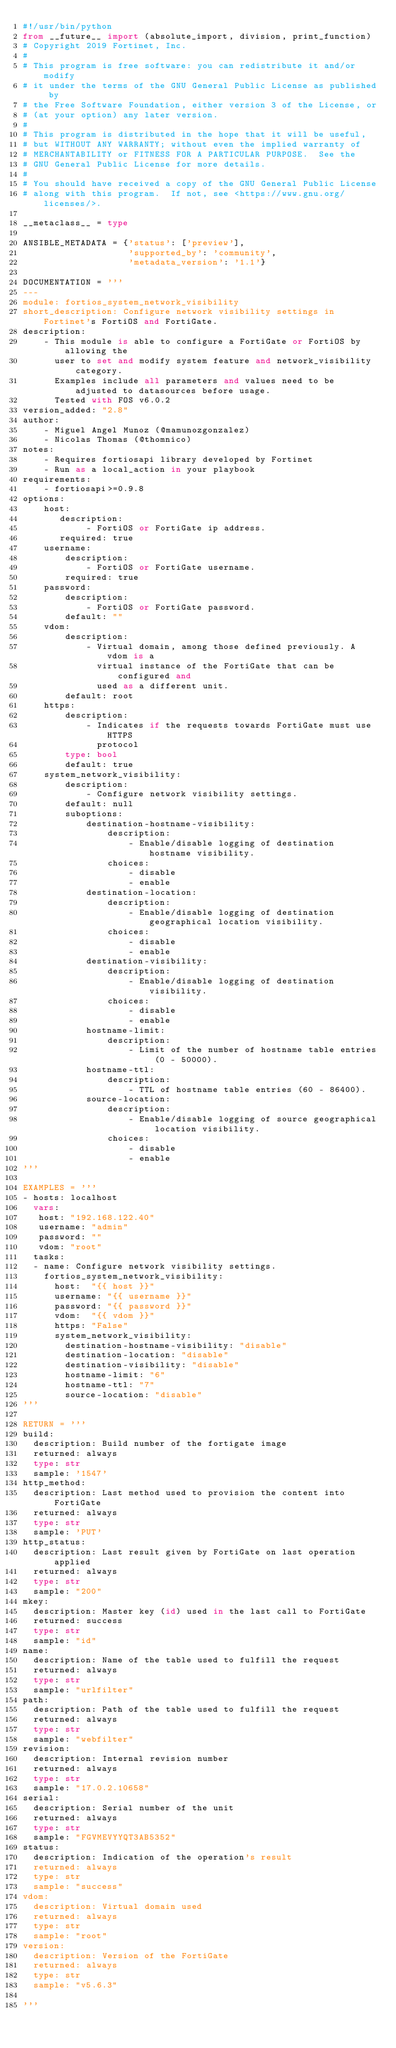<code> <loc_0><loc_0><loc_500><loc_500><_Python_>#!/usr/bin/python
from __future__ import (absolute_import, division, print_function)
# Copyright 2019 Fortinet, Inc.
#
# This program is free software: you can redistribute it and/or modify
# it under the terms of the GNU General Public License as published by
# the Free Software Foundation, either version 3 of the License, or
# (at your option) any later version.
#
# This program is distributed in the hope that it will be useful,
# but WITHOUT ANY WARRANTY; without even the implied warranty of
# MERCHANTABILITY or FITNESS FOR A PARTICULAR PURPOSE.  See the
# GNU General Public License for more details.
#
# You should have received a copy of the GNU General Public License
# along with this program.  If not, see <https://www.gnu.org/licenses/>.

__metaclass__ = type

ANSIBLE_METADATA = {'status': ['preview'],
                    'supported_by': 'community',
                    'metadata_version': '1.1'}

DOCUMENTATION = '''
---
module: fortios_system_network_visibility
short_description: Configure network visibility settings in Fortinet's FortiOS and FortiGate.
description:
    - This module is able to configure a FortiGate or FortiOS by allowing the
      user to set and modify system feature and network_visibility category.
      Examples include all parameters and values need to be adjusted to datasources before usage.
      Tested with FOS v6.0.2
version_added: "2.8"
author:
    - Miguel Angel Munoz (@mamunozgonzalez)
    - Nicolas Thomas (@thomnico)
notes:
    - Requires fortiosapi library developed by Fortinet
    - Run as a local_action in your playbook
requirements:
    - fortiosapi>=0.9.8
options:
    host:
       description:
            - FortiOS or FortiGate ip address.
       required: true
    username:
        description:
            - FortiOS or FortiGate username.
        required: true
    password:
        description:
            - FortiOS or FortiGate password.
        default: ""
    vdom:
        description:
            - Virtual domain, among those defined previously. A vdom is a
              virtual instance of the FortiGate that can be configured and
              used as a different unit.
        default: root
    https:
        description:
            - Indicates if the requests towards FortiGate must use HTTPS
              protocol
        type: bool
        default: true
    system_network_visibility:
        description:
            - Configure network visibility settings.
        default: null
        suboptions:
            destination-hostname-visibility:
                description:
                    - Enable/disable logging of destination hostname visibility.
                choices:
                    - disable
                    - enable
            destination-location:
                description:
                    - Enable/disable logging of destination geographical location visibility.
                choices:
                    - disable
                    - enable
            destination-visibility:
                description:
                    - Enable/disable logging of destination visibility.
                choices:
                    - disable
                    - enable
            hostname-limit:
                description:
                    - Limit of the number of hostname table entries (0 - 50000).
            hostname-ttl:
                description:
                    - TTL of hostname table entries (60 - 86400).
            source-location:
                description:
                    - Enable/disable logging of source geographical location visibility.
                choices:
                    - disable
                    - enable
'''

EXAMPLES = '''
- hosts: localhost
  vars:
   host: "192.168.122.40"
   username: "admin"
   password: ""
   vdom: "root"
  tasks:
  - name: Configure network visibility settings.
    fortios_system_network_visibility:
      host:  "{{ host }}"
      username: "{{ username }}"
      password: "{{ password }}"
      vdom:  "{{ vdom }}"
      https: "False"
      system_network_visibility:
        destination-hostname-visibility: "disable"
        destination-location: "disable"
        destination-visibility: "disable"
        hostname-limit: "6"
        hostname-ttl: "7"
        source-location: "disable"
'''

RETURN = '''
build:
  description: Build number of the fortigate image
  returned: always
  type: str
  sample: '1547'
http_method:
  description: Last method used to provision the content into FortiGate
  returned: always
  type: str
  sample: 'PUT'
http_status:
  description: Last result given by FortiGate on last operation applied
  returned: always
  type: str
  sample: "200"
mkey:
  description: Master key (id) used in the last call to FortiGate
  returned: success
  type: str
  sample: "id"
name:
  description: Name of the table used to fulfill the request
  returned: always
  type: str
  sample: "urlfilter"
path:
  description: Path of the table used to fulfill the request
  returned: always
  type: str
  sample: "webfilter"
revision:
  description: Internal revision number
  returned: always
  type: str
  sample: "17.0.2.10658"
serial:
  description: Serial number of the unit
  returned: always
  type: str
  sample: "FGVMEVYYQT3AB5352"
status:
  description: Indication of the operation's result
  returned: always
  type: str
  sample: "success"
vdom:
  description: Virtual domain used
  returned: always
  type: str
  sample: "root"
version:
  description: Version of the FortiGate
  returned: always
  type: str
  sample: "v5.6.3"

'''
</code> 